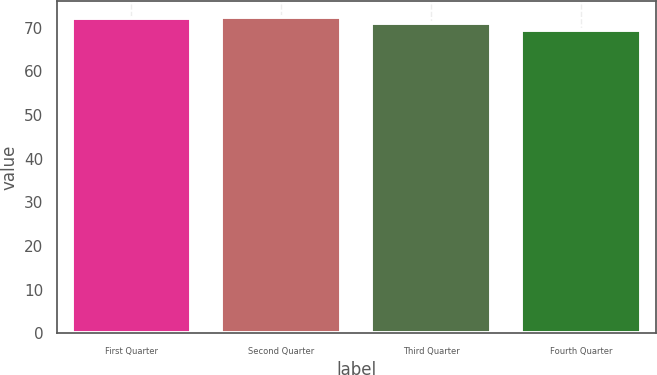Convert chart. <chart><loc_0><loc_0><loc_500><loc_500><bar_chart><fcel>First Quarter<fcel>Second Quarter<fcel>Third Quarter<fcel>Fourth Quarter<nl><fcel>72.15<fcel>72.41<fcel>71.18<fcel>69.56<nl></chart> 